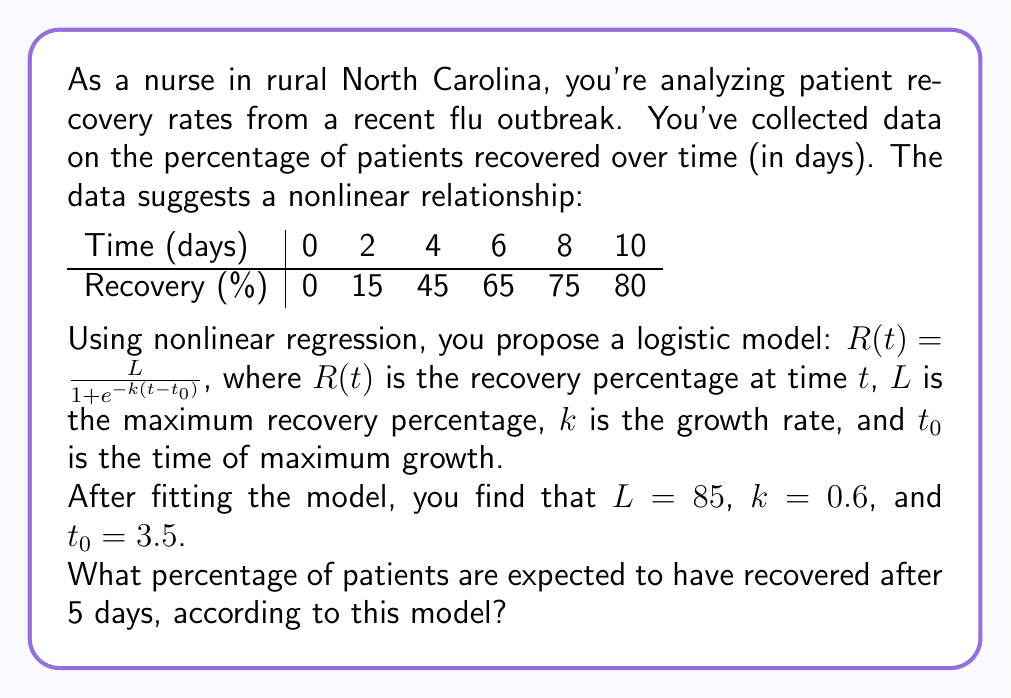Teach me how to tackle this problem. To solve this problem, we'll follow these steps:

1) We have the logistic model: $R(t) = \frac{L}{1 + e^{-k(t-t_0)}}$

2) We're given the parameters:
   $L = 85$ (maximum recovery percentage)
   $k = 0.6$ (growth rate)
   $t_0 = 3.5$ (time of maximum growth)

3) We need to find $R(5)$, the recovery percentage at $t = 5$ days.

4) Let's substitute these values into our equation:

   $R(5) = \frac{85}{1 + e^{-0.6(5-3.5)}}$

5) Simplify the exponent:
   $R(5) = \frac{85}{1 + e^{-0.6(1.5)}}$

6) Calculate the exponent:
   $R(5) = \frac{85}{1 + e^{-0.9}}$

7) Calculate $e^{-0.9}$:
   $e^{-0.9} \approx 0.4066$

8) Substitute this value:
   $R(5) = \frac{85}{1 + 0.4066}$

9) Calculate the denominator:
   $R(5) = \frac{85}{1.4066}$

10) Divide:
    $R(5) \approx 60.43$

11) Round to the nearest whole percentage:
    $R(5) \approx 60%$

Therefore, according to this model, approximately 60% of patients are expected to have recovered after 5 days.
Answer: 60% 